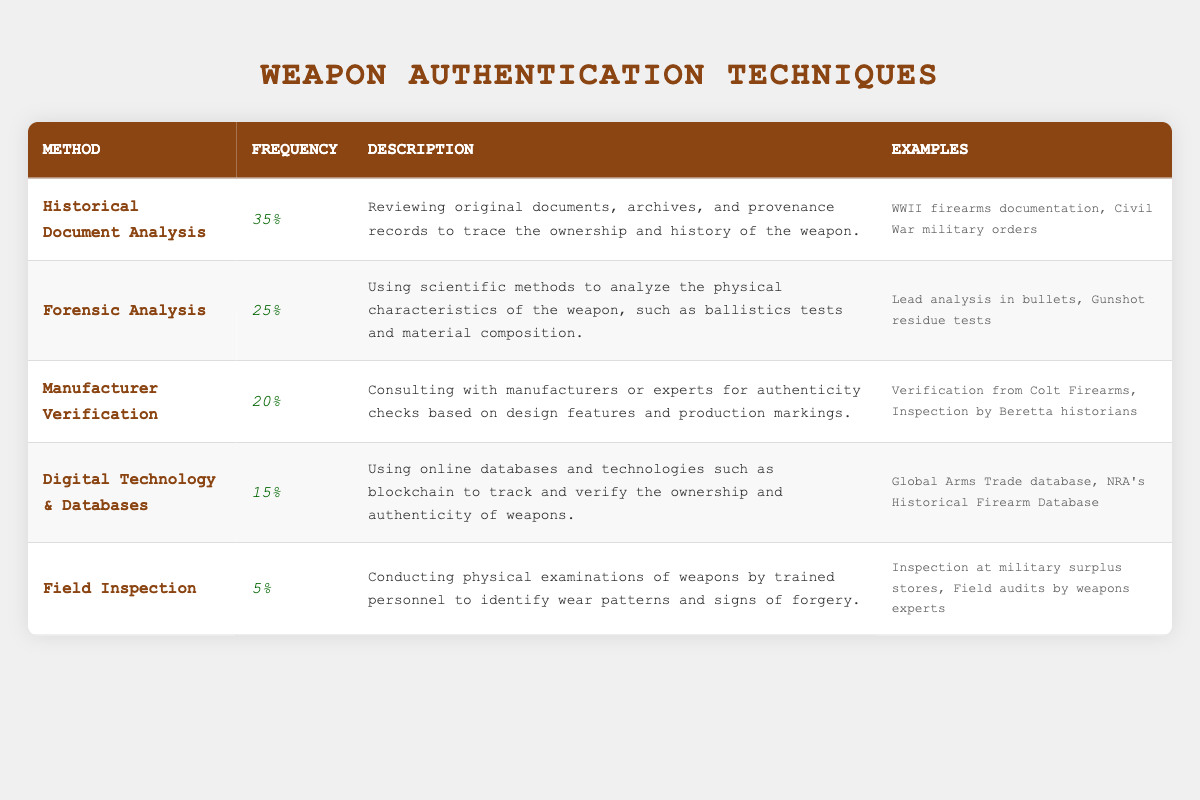What is the most frequently used weapon authentication method? The table indicates that "Historical Document Analysis" has the highest frequency at 35%, making it the most frequently used method for weapon authentication.
Answer: Historical Document Analysis What percentage of weapon authentication techniques involve forensic analysis? The table shows that "Forensic Analysis" has a frequency of 25%. Therefore, 25% of the techniques involve forensic analysis.
Answer: 25% Which method has the least frequency among weapon authentication techniques? According to the table, "Field Inspection" has the least frequency at 5%, indicating it is the least used method of those listed.
Answer: Field Inspection Is "Digital Technology & Databases" used more frequently than "Field Inspection"? Yes, "Digital Technology & Databases" has a frequency of 15%, which is higher than "Field Inspection" at 5%. Therefore, it is used more frequently.
Answer: Yes If we consider all the methods listed, what is the combined frequency of "Manufacturer Verification" and "Forensic Analysis"? "Manufacturer Verification" is at 20% and "Forensic Analysis" is at 25%. Adding these two percentages gives 20% + 25% = 45%. Thus, the combined frequency is 45%.
Answer: 45% What percentage of weapon authentication techniques is related to either historical document analysis or forensic analysis? The frequency of "Historical Document Analysis" is 35% and "Forensic Analysis" is 25%. Adding these together gives 35% + 25% = 60%. Therefore, 60% of the techniques relate to these two methods.
Answer: 60% Is it true that at least one authentication method has a frequency of 20% or higher? Yes, as seen in the table, "Historical Document Analysis" (35%), "Forensic Analysis" (25%), and "Manufacturer Verification" (20%) all have frequencies of 20% or higher. Therefore, the statement is true.
Answer: Yes What is the average frequency of the five weapon authentication techniques listed in the table? To find the average, add all the frequencies: 35% + 25% + 20% + 15% + 5% = 100%. Then divide by the number of techniques, which is 5: 100%/5 = 20%. Thus, the average frequency is 20%.
Answer: 20% What method falls in between "Forensic Analysis" and "Digital Technology & Databases" in terms of frequency? "Manufacturer Verification" has a frequency of 20%, which lies between "Forensic Analysis" at 25% and "Digital Technology & Databases" at 15%. This makes it the method that falls in between.
Answer: Manufacturer Verification 